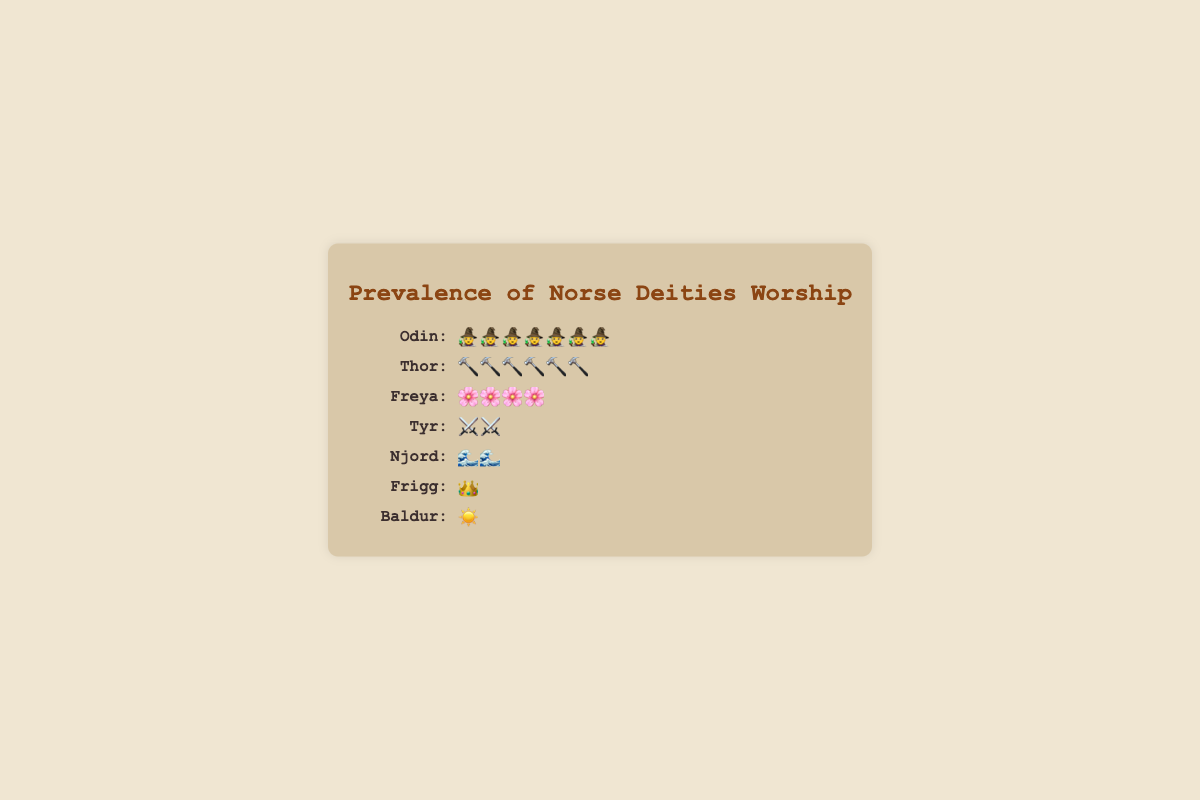Which deity has the highest number of worshippers? The figure shows icons representing the number of worshippers. The deity with the most icons is Odin.
Answer: Odin How many icons represent Frigg? Each deity has a certain number of icons next to their name. Frigg is represented by a crown icon, and there is only one such icon.
Answer: 1 What is the total number of worshippers for Tyr and Njord combined? To find the total number of worshippers for both Tyr and Njord, count the icons for each deity and add them up. Tyr has 10 icons (⚔️), and Njord has 8 icons (🌊). Therefore, 10 + 8 = 18.
Answer: 18 Which deity has more worshippers, Thor or Freya? To determine which deity has more worshippers, compare the number of icons for Thor and Freya. Thor has 30 icons (🔨), and Freya has 20 icons (🌸). Thor has more worshippers.
Answer: Thor What is the difference in the number of worshippers between Odin and Baldur? Odin has 35 icons (🧙), and Baldur has 5 icons (☀️). Subtract the number of Baldur's icons from Odin's, which gives 35 - 5.
Answer: 30 Are the numbers of icons for Njord and Frigg equal? Compare the number of icons for Njord and Frigg. Njord has 8 icons (🌊), and Frigg has 7 icons (👑). They are not equal.
Answer: No Which deity has the fewest worshippers? Look at the deity with the least number of icons compared to all others. Baldur has the fewest number of icons, which is 5.
Answer: Baldur By how many worshippers does Freya exceed Tyr? Freya has 20 icons (🌸), and Tyr has 10 icons (⚔️). Subtract Tyr's icons from Freya's, which gives 20 - 10.
Answer: 10 List the deities in descending order of worshippers. Arrange the deities by the number of icons in descending order: Odin (35), Thor (30), Freya (20), Tyr (10), Njord (8), Frigg (7), Baldur (5).
Answer: Odin, Thor, Freya, Tyr, Njord, Frigg, Baldur How many worshippers in total are represented in the figure? Add up all the icons for each deity: Odin (35), Thor (30), Freya (20), Tyr (10), Njord (8), Frigg (7), Baldur (5). The total is 35 + 30 + 20 + 10 + 8 + 7 + 5.
Answer: 115 